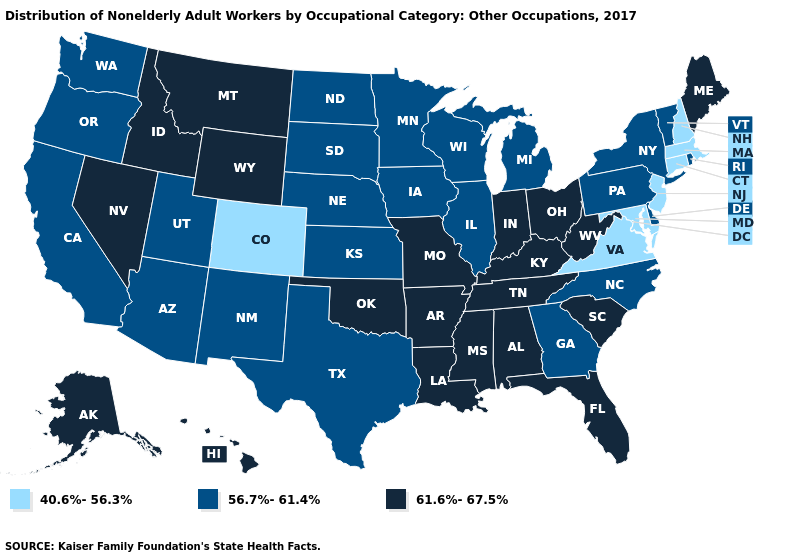What is the highest value in the USA?
Quick response, please. 61.6%-67.5%. Among the states that border West Virginia , which have the lowest value?
Short answer required. Maryland, Virginia. What is the value of Montana?
Short answer required. 61.6%-67.5%. Does Maine have the highest value in the Northeast?
Be succinct. Yes. Does Michigan have the highest value in the USA?
Write a very short answer. No. Among the states that border New York , which have the highest value?
Be succinct. Pennsylvania, Vermont. How many symbols are there in the legend?
Concise answer only. 3. Does Maryland have the lowest value in the USA?
Answer briefly. Yes. Which states have the lowest value in the Northeast?
Write a very short answer. Connecticut, Massachusetts, New Hampshire, New Jersey. Does the map have missing data?
Give a very brief answer. No. Which states hav the highest value in the South?
Short answer required. Alabama, Arkansas, Florida, Kentucky, Louisiana, Mississippi, Oklahoma, South Carolina, Tennessee, West Virginia. Among the states that border Ohio , does West Virginia have the highest value?
Be succinct. Yes. Name the states that have a value in the range 40.6%-56.3%?
Concise answer only. Colorado, Connecticut, Maryland, Massachusetts, New Hampshire, New Jersey, Virginia. Name the states that have a value in the range 56.7%-61.4%?
Short answer required. Arizona, California, Delaware, Georgia, Illinois, Iowa, Kansas, Michigan, Minnesota, Nebraska, New Mexico, New York, North Carolina, North Dakota, Oregon, Pennsylvania, Rhode Island, South Dakota, Texas, Utah, Vermont, Washington, Wisconsin. What is the value of Texas?
Write a very short answer. 56.7%-61.4%. 